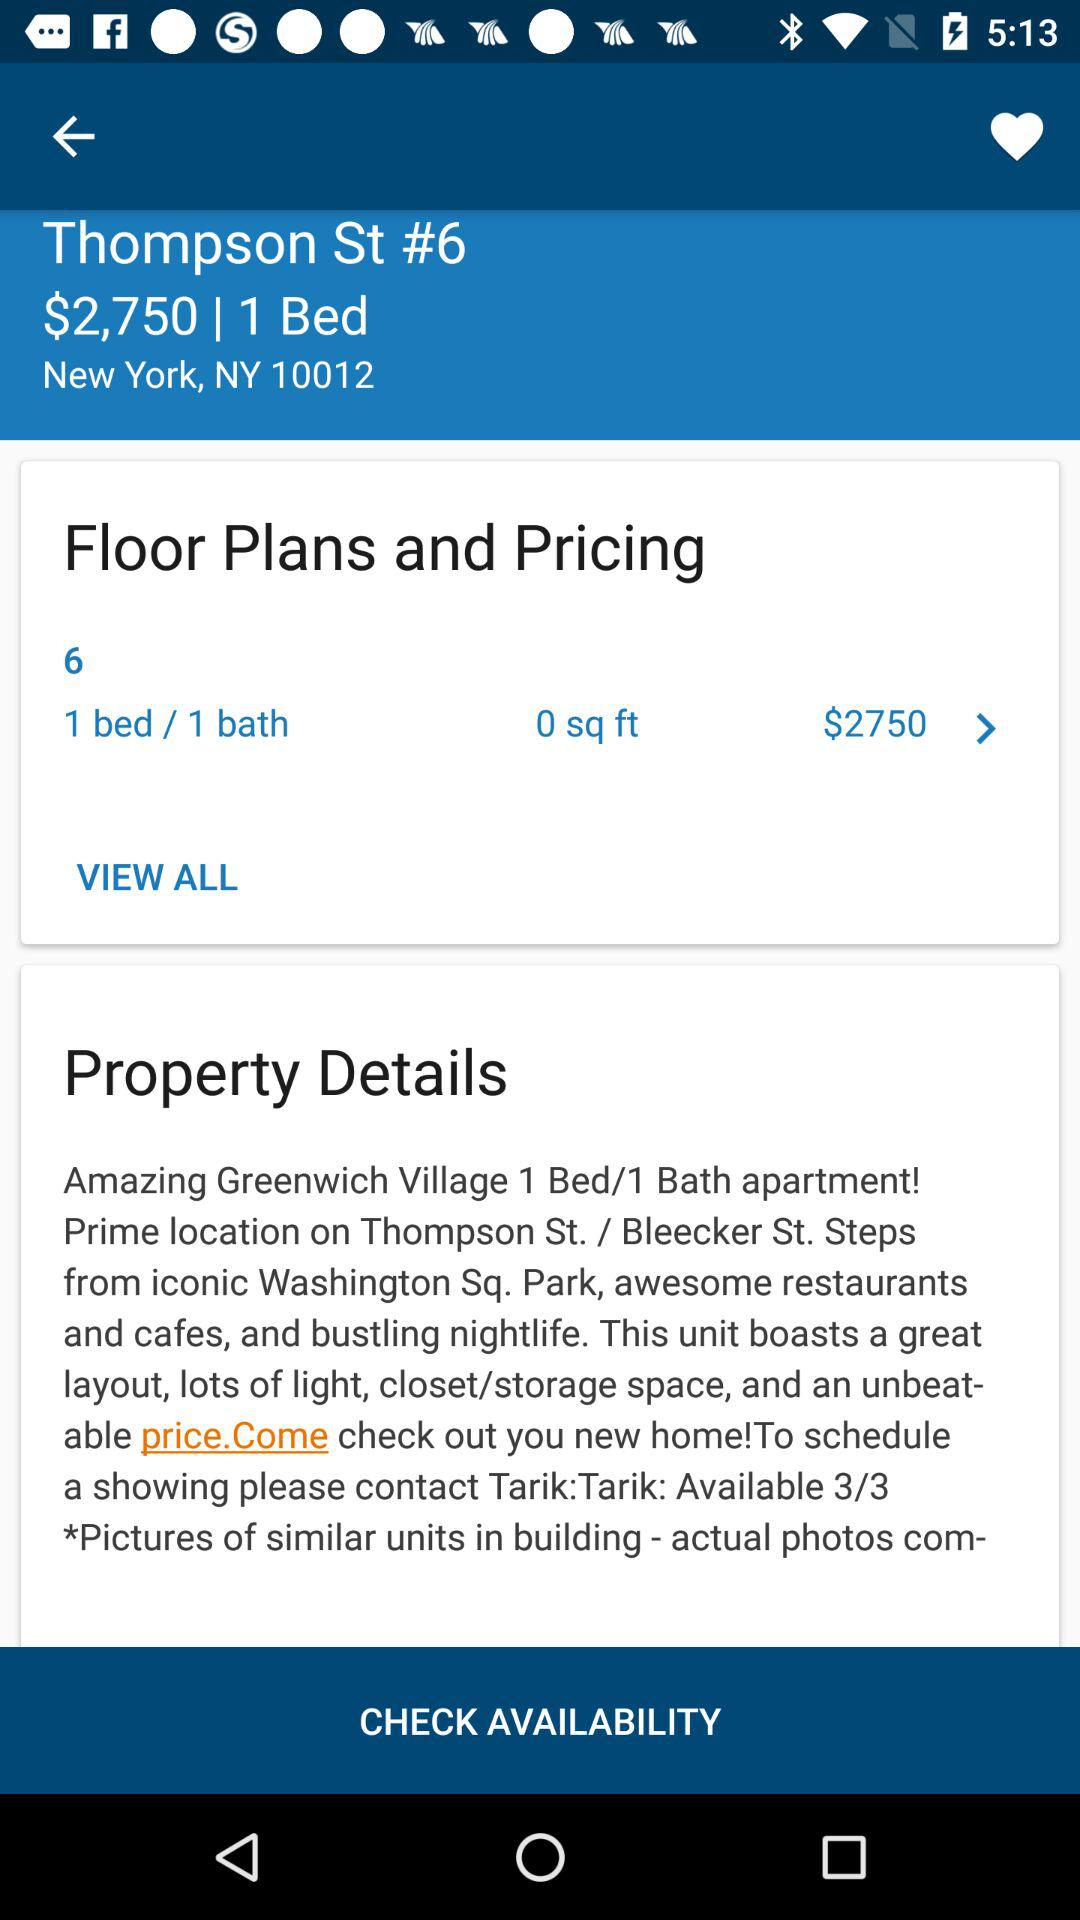At what time will the apartment be available?
When the provided information is insufficient, respond with <no answer>. <no answer> 